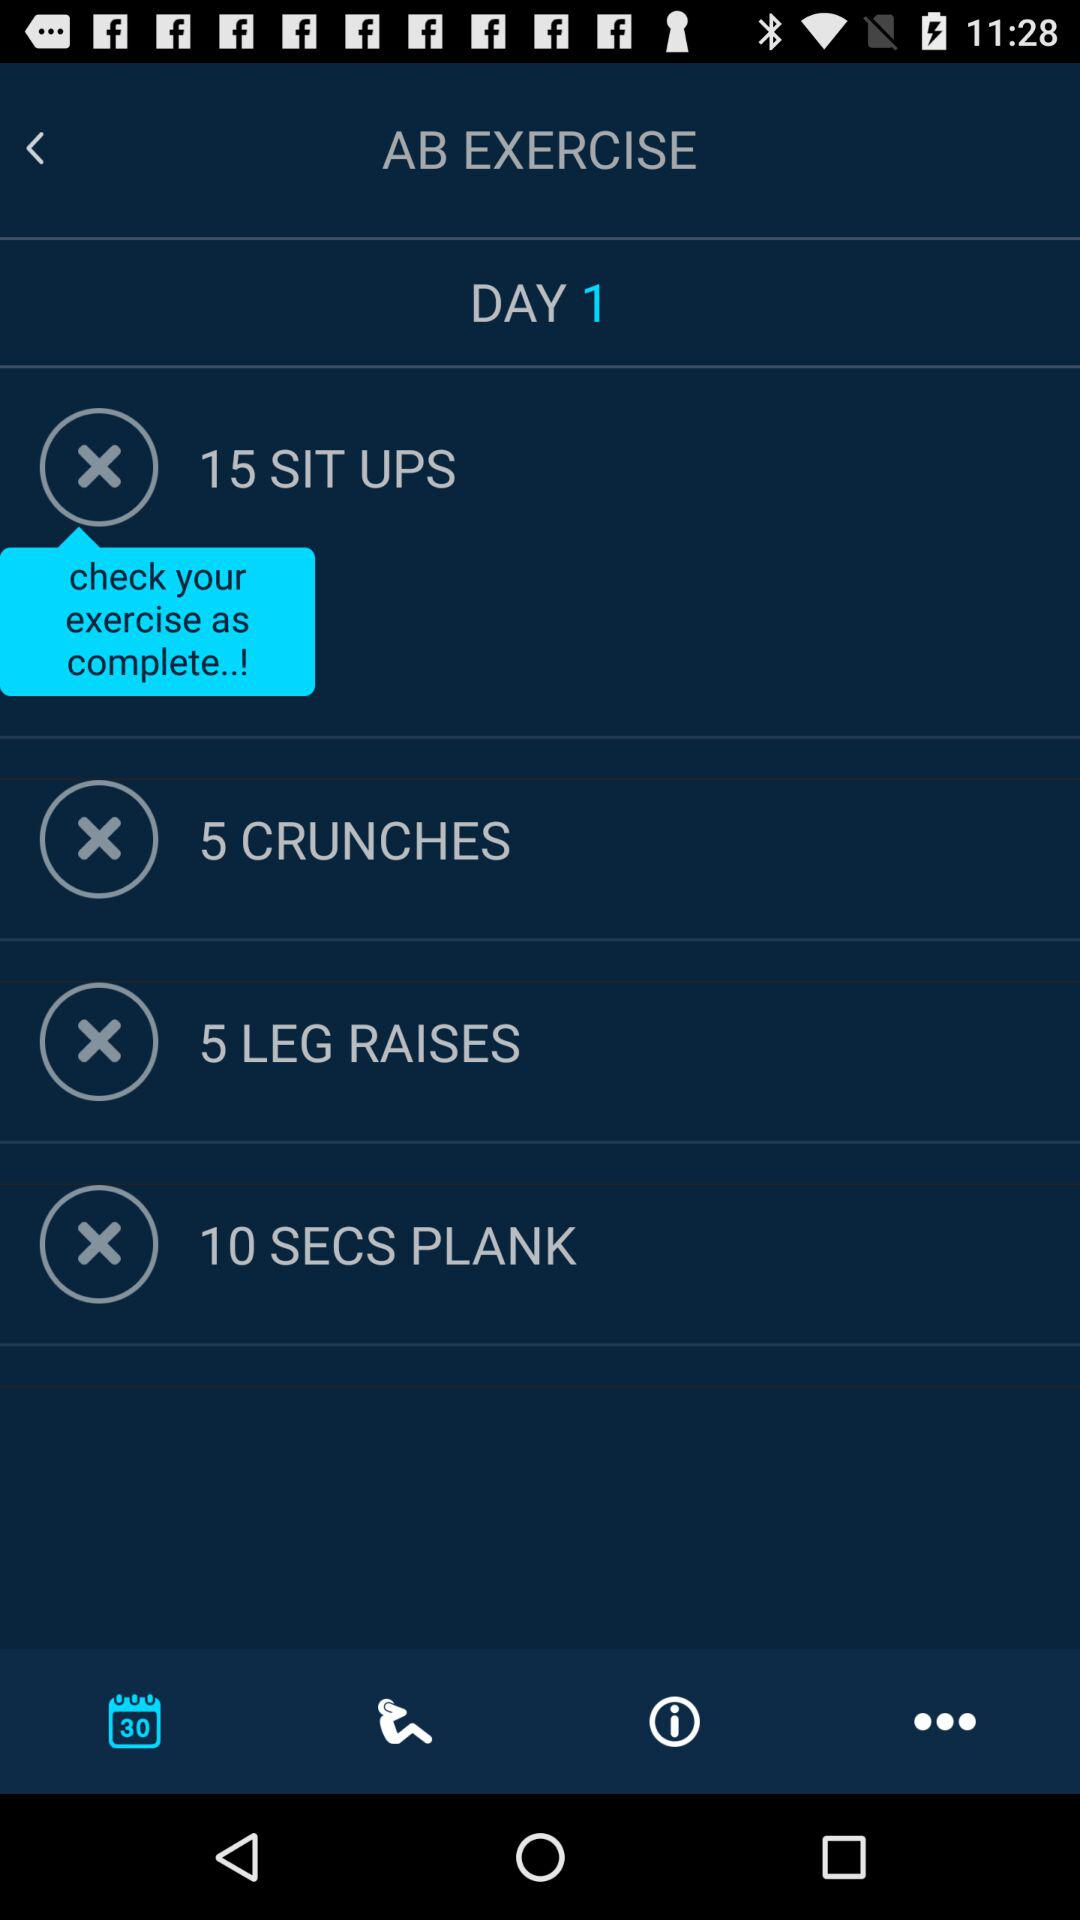How many exercises are there in total?
Answer the question using a single word or phrase. 4 